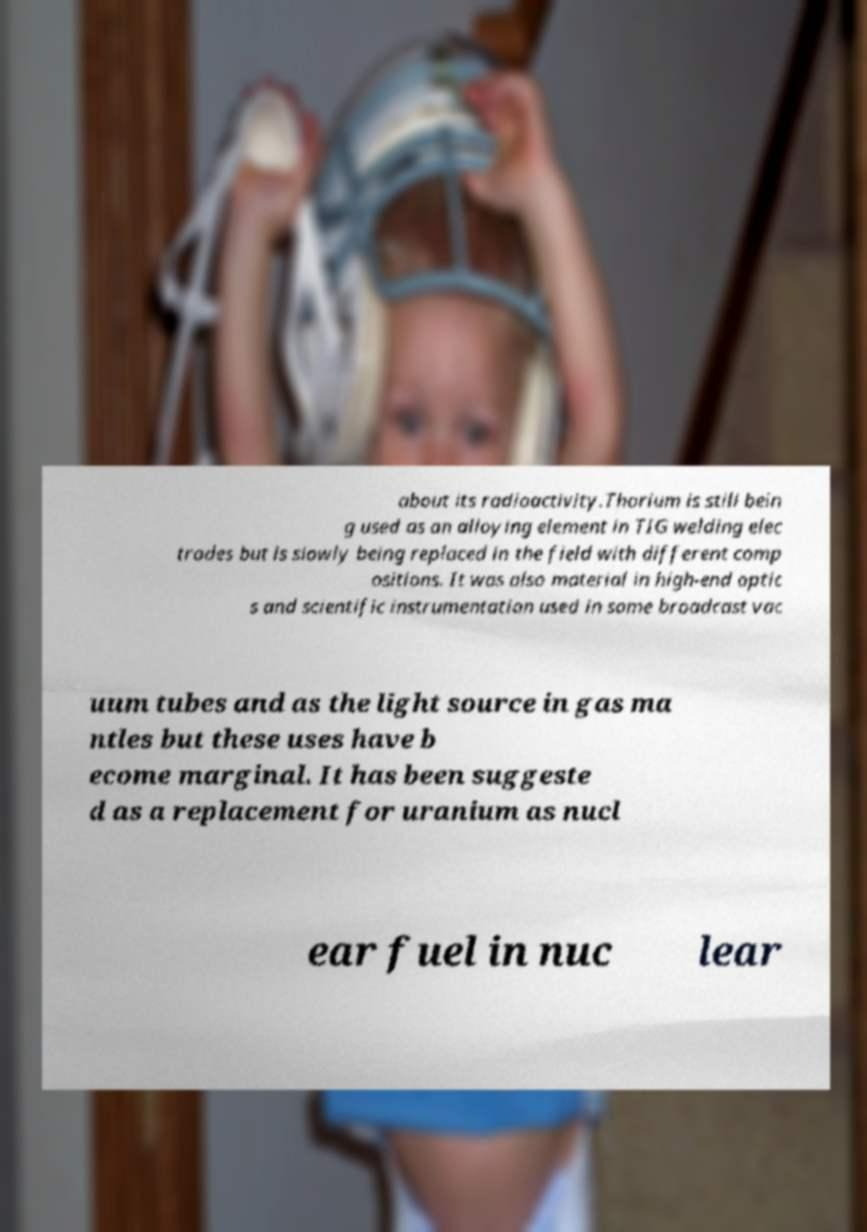Can you accurately transcribe the text from the provided image for me? about its radioactivity.Thorium is still bein g used as an alloying element in TIG welding elec trodes but is slowly being replaced in the field with different comp ositions. It was also material in high-end optic s and scientific instrumentation used in some broadcast vac uum tubes and as the light source in gas ma ntles but these uses have b ecome marginal. It has been suggeste d as a replacement for uranium as nucl ear fuel in nuc lear 